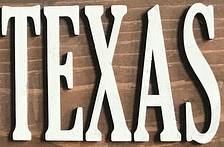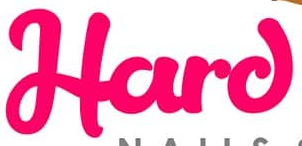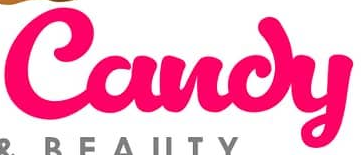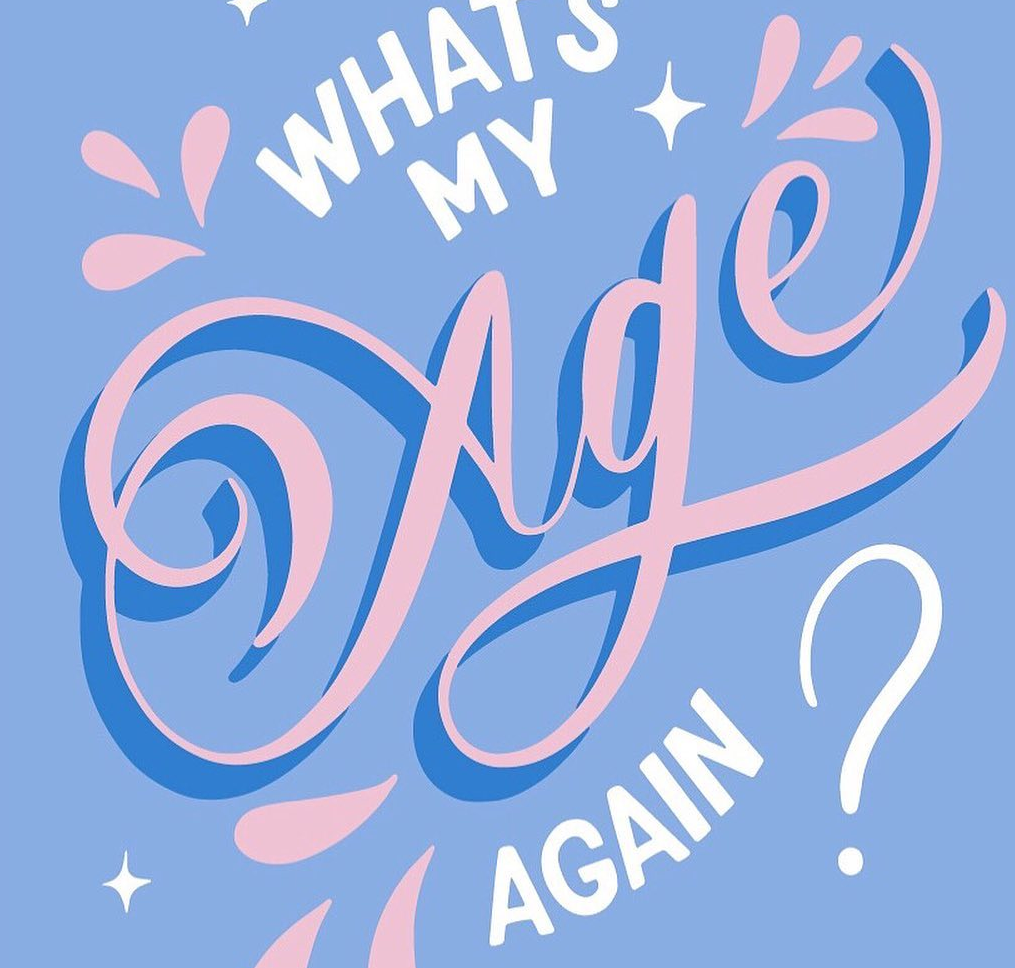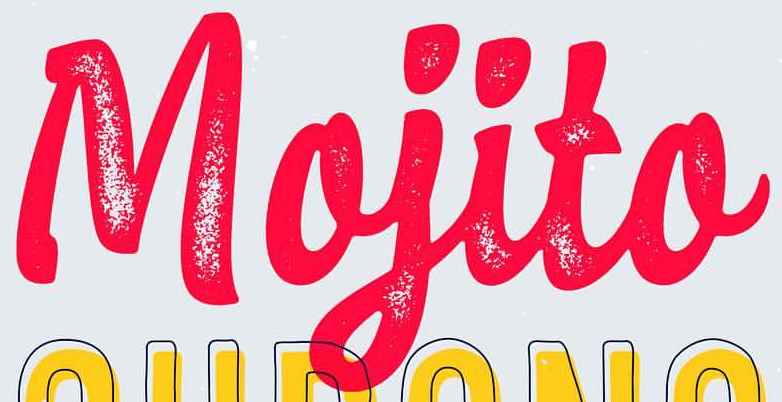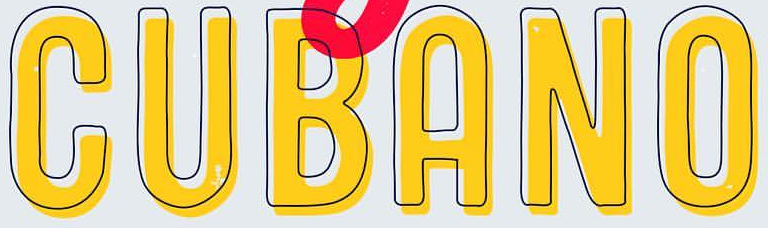What words are shown in these images in order, separated by a semicolon? TEXAS; Hard; Candy; Age; Mojito; CUBANO 